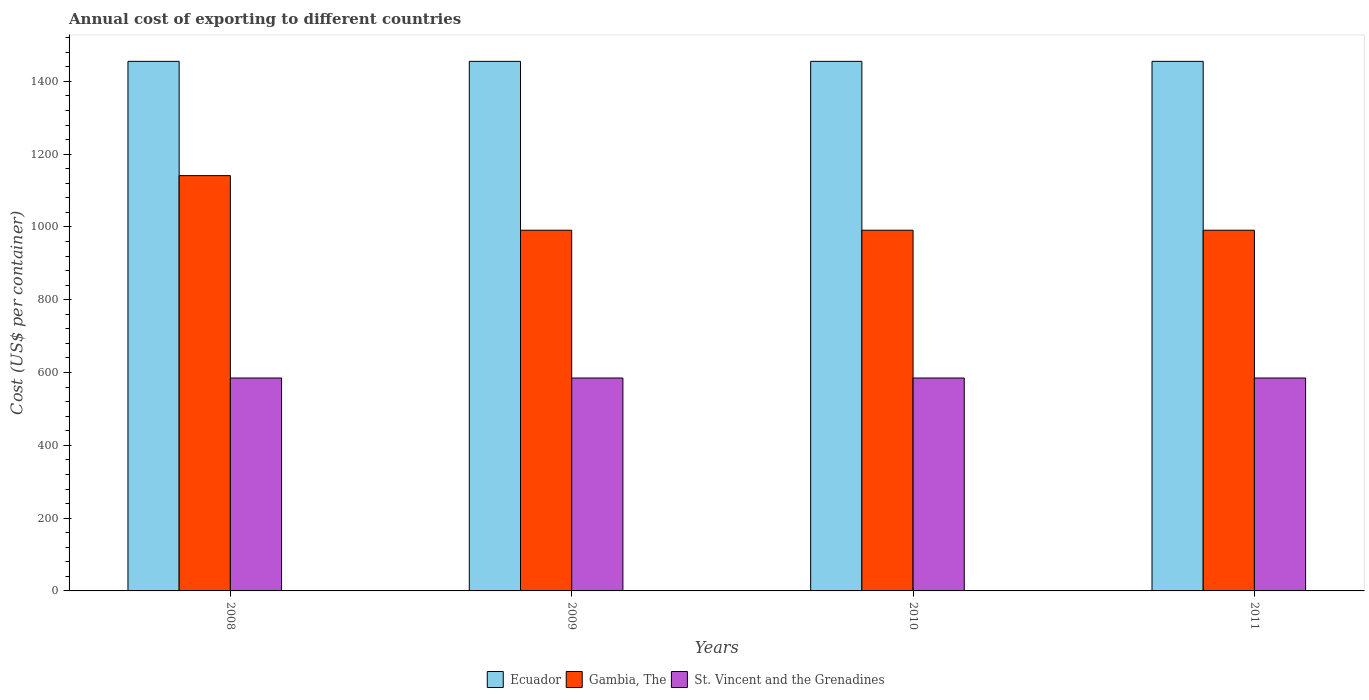How many different coloured bars are there?
Make the answer very short. 3. Are the number of bars on each tick of the X-axis equal?
Make the answer very short. Yes. In how many cases, is the number of bars for a given year not equal to the number of legend labels?
Offer a terse response. 0. What is the total annual cost of exporting in St. Vincent and the Grenadines in 2009?
Give a very brief answer. 585. Across all years, what is the maximum total annual cost of exporting in Ecuador?
Provide a succinct answer. 1455. Across all years, what is the minimum total annual cost of exporting in St. Vincent and the Grenadines?
Offer a terse response. 585. In which year was the total annual cost of exporting in Gambia, The maximum?
Provide a short and direct response. 2008. In which year was the total annual cost of exporting in St. Vincent and the Grenadines minimum?
Your answer should be compact. 2008. What is the total total annual cost of exporting in St. Vincent and the Grenadines in the graph?
Offer a terse response. 2340. What is the difference between the total annual cost of exporting in Gambia, The in 2011 and the total annual cost of exporting in Ecuador in 2009?
Your answer should be very brief. -464. What is the average total annual cost of exporting in St. Vincent and the Grenadines per year?
Your answer should be very brief. 585. In the year 2010, what is the difference between the total annual cost of exporting in Ecuador and total annual cost of exporting in Gambia, The?
Give a very brief answer. 464. In how many years, is the total annual cost of exporting in St. Vincent and the Grenadines greater than 840 US$?
Provide a short and direct response. 0. What is the ratio of the total annual cost of exporting in Gambia, The in 2008 to that in 2009?
Keep it short and to the point. 1.15. Is the total annual cost of exporting in Gambia, The in 2009 less than that in 2010?
Provide a short and direct response. No. What is the difference between the highest and the second highest total annual cost of exporting in St. Vincent and the Grenadines?
Keep it short and to the point. 0. What does the 1st bar from the left in 2008 represents?
Your response must be concise. Ecuador. What does the 3rd bar from the right in 2009 represents?
Provide a short and direct response. Ecuador. Is it the case that in every year, the sum of the total annual cost of exporting in Gambia, The and total annual cost of exporting in Ecuador is greater than the total annual cost of exporting in St. Vincent and the Grenadines?
Offer a terse response. Yes. How many bars are there?
Keep it short and to the point. 12. How many years are there in the graph?
Your answer should be very brief. 4. How are the legend labels stacked?
Your answer should be very brief. Horizontal. What is the title of the graph?
Ensure brevity in your answer.  Annual cost of exporting to different countries. Does "Serbia" appear as one of the legend labels in the graph?
Offer a very short reply. No. What is the label or title of the X-axis?
Your answer should be compact. Years. What is the label or title of the Y-axis?
Make the answer very short. Cost (US$ per container). What is the Cost (US$ per container) of Ecuador in 2008?
Provide a succinct answer. 1455. What is the Cost (US$ per container) of Gambia, The in 2008?
Provide a short and direct response. 1141. What is the Cost (US$ per container) of St. Vincent and the Grenadines in 2008?
Keep it short and to the point. 585. What is the Cost (US$ per container) in Ecuador in 2009?
Your response must be concise. 1455. What is the Cost (US$ per container) of Gambia, The in 2009?
Keep it short and to the point. 991. What is the Cost (US$ per container) of St. Vincent and the Grenadines in 2009?
Provide a succinct answer. 585. What is the Cost (US$ per container) in Ecuador in 2010?
Provide a succinct answer. 1455. What is the Cost (US$ per container) of Gambia, The in 2010?
Keep it short and to the point. 991. What is the Cost (US$ per container) of St. Vincent and the Grenadines in 2010?
Your answer should be compact. 585. What is the Cost (US$ per container) in Ecuador in 2011?
Your response must be concise. 1455. What is the Cost (US$ per container) in Gambia, The in 2011?
Provide a short and direct response. 991. What is the Cost (US$ per container) of St. Vincent and the Grenadines in 2011?
Provide a succinct answer. 585. Across all years, what is the maximum Cost (US$ per container) in Ecuador?
Make the answer very short. 1455. Across all years, what is the maximum Cost (US$ per container) in Gambia, The?
Your answer should be compact. 1141. Across all years, what is the maximum Cost (US$ per container) of St. Vincent and the Grenadines?
Your answer should be compact. 585. Across all years, what is the minimum Cost (US$ per container) in Ecuador?
Your response must be concise. 1455. Across all years, what is the minimum Cost (US$ per container) in Gambia, The?
Provide a short and direct response. 991. Across all years, what is the minimum Cost (US$ per container) in St. Vincent and the Grenadines?
Your response must be concise. 585. What is the total Cost (US$ per container) in Ecuador in the graph?
Provide a succinct answer. 5820. What is the total Cost (US$ per container) in Gambia, The in the graph?
Your answer should be very brief. 4114. What is the total Cost (US$ per container) in St. Vincent and the Grenadines in the graph?
Make the answer very short. 2340. What is the difference between the Cost (US$ per container) in Ecuador in 2008 and that in 2009?
Your response must be concise. 0. What is the difference between the Cost (US$ per container) in Gambia, The in 2008 and that in 2009?
Make the answer very short. 150. What is the difference between the Cost (US$ per container) of St. Vincent and the Grenadines in 2008 and that in 2009?
Keep it short and to the point. 0. What is the difference between the Cost (US$ per container) in Ecuador in 2008 and that in 2010?
Your response must be concise. 0. What is the difference between the Cost (US$ per container) in Gambia, The in 2008 and that in 2010?
Ensure brevity in your answer.  150. What is the difference between the Cost (US$ per container) of Ecuador in 2008 and that in 2011?
Offer a very short reply. 0. What is the difference between the Cost (US$ per container) in Gambia, The in 2008 and that in 2011?
Your answer should be compact. 150. What is the difference between the Cost (US$ per container) of St. Vincent and the Grenadines in 2008 and that in 2011?
Keep it short and to the point. 0. What is the difference between the Cost (US$ per container) in St. Vincent and the Grenadines in 2009 and that in 2010?
Give a very brief answer. 0. What is the difference between the Cost (US$ per container) in Ecuador in 2009 and that in 2011?
Offer a very short reply. 0. What is the difference between the Cost (US$ per container) of Ecuador in 2010 and that in 2011?
Offer a terse response. 0. What is the difference between the Cost (US$ per container) in Gambia, The in 2010 and that in 2011?
Give a very brief answer. 0. What is the difference between the Cost (US$ per container) in Ecuador in 2008 and the Cost (US$ per container) in Gambia, The in 2009?
Offer a very short reply. 464. What is the difference between the Cost (US$ per container) in Ecuador in 2008 and the Cost (US$ per container) in St. Vincent and the Grenadines in 2009?
Your answer should be compact. 870. What is the difference between the Cost (US$ per container) of Gambia, The in 2008 and the Cost (US$ per container) of St. Vincent and the Grenadines in 2009?
Provide a succinct answer. 556. What is the difference between the Cost (US$ per container) of Ecuador in 2008 and the Cost (US$ per container) of Gambia, The in 2010?
Give a very brief answer. 464. What is the difference between the Cost (US$ per container) in Ecuador in 2008 and the Cost (US$ per container) in St. Vincent and the Grenadines in 2010?
Make the answer very short. 870. What is the difference between the Cost (US$ per container) of Gambia, The in 2008 and the Cost (US$ per container) of St. Vincent and the Grenadines in 2010?
Your answer should be compact. 556. What is the difference between the Cost (US$ per container) of Ecuador in 2008 and the Cost (US$ per container) of Gambia, The in 2011?
Provide a short and direct response. 464. What is the difference between the Cost (US$ per container) of Ecuador in 2008 and the Cost (US$ per container) of St. Vincent and the Grenadines in 2011?
Offer a terse response. 870. What is the difference between the Cost (US$ per container) of Gambia, The in 2008 and the Cost (US$ per container) of St. Vincent and the Grenadines in 2011?
Make the answer very short. 556. What is the difference between the Cost (US$ per container) of Ecuador in 2009 and the Cost (US$ per container) of Gambia, The in 2010?
Keep it short and to the point. 464. What is the difference between the Cost (US$ per container) in Ecuador in 2009 and the Cost (US$ per container) in St. Vincent and the Grenadines in 2010?
Ensure brevity in your answer.  870. What is the difference between the Cost (US$ per container) of Gambia, The in 2009 and the Cost (US$ per container) of St. Vincent and the Grenadines in 2010?
Keep it short and to the point. 406. What is the difference between the Cost (US$ per container) of Ecuador in 2009 and the Cost (US$ per container) of Gambia, The in 2011?
Keep it short and to the point. 464. What is the difference between the Cost (US$ per container) in Ecuador in 2009 and the Cost (US$ per container) in St. Vincent and the Grenadines in 2011?
Provide a short and direct response. 870. What is the difference between the Cost (US$ per container) of Gambia, The in 2009 and the Cost (US$ per container) of St. Vincent and the Grenadines in 2011?
Offer a terse response. 406. What is the difference between the Cost (US$ per container) of Ecuador in 2010 and the Cost (US$ per container) of Gambia, The in 2011?
Provide a short and direct response. 464. What is the difference between the Cost (US$ per container) of Ecuador in 2010 and the Cost (US$ per container) of St. Vincent and the Grenadines in 2011?
Make the answer very short. 870. What is the difference between the Cost (US$ per container) of Gambia, The in 2010 and the Cost (US$ per container) of St. Vincent and the Grenadines in 2011?
Give a very brief answer. 406. What is the average Cost (US$ per container) of Ecuador per year?
Make the answer very short. 1455. What is the average Cost (US$ per container) in Gambia, The per year?
Offer a terse response. 1028.5. What is the average Cost (US$ per container) in St. Vincent and the Grenadines per year?
Keep it short and to the point. 585. In the year 2008, what is the difference between the Cost (US$ per container) in Ecuador and Cost (US$ per container) in Gambia, The?
Offer a very short reply. 314. In the year 2008, what is the difference between the Cost (US$ per container) of Ecuador and Cost (US$ per container) of St. Vincent and the Grenadines?
Give a very brief answer. 870. In the year 2008, what is the difference between the Cost (US$ per container) in Gambia, The and Cost (US$ per container) in St. Vincent and the Grenadines?
Offer a very short reply. 556. In the year 2009, what is the difference between the Cost (US$ per container) in Ecuador and Cost (US$ per container) in Gambia, The?
Your answer should be very brief. 464. In the year 2009, what is the difference between the Cost (US$ per container) of Ecuador and Cost (US$ per container) of St. Vincent and the Grenadines?
Keep it short and to the point. 870. In the year 2009, what is the difference between the Cost (US$ per container) of Gambia, The and Cost (US$ per container) of St. Vincent and the Grenadines?
Offer a very short reply. 406. In the year 2010, what is the difference between the Cost (US$ per container) in Ecuador and Cost (US$ per container) in Gambia, The?
Your answer should be very brief. 464. In the year 2010, what is the difference between the Cost (US$ per container) in Ecuador and Cost (US$ per container) in St. Vincent and the Grenadines?
Provide a short and direct response. 870. In the year 2010, what is the difference between the Cost (US$ per container) in Gambia, The and Cost (US$ per container) in St. Vincent and the Grenadines?
Keep it short and to the point. 406. In the year 2011, what is the difference between the Cost (US$ per container) in Ecuador and Cost (US$ per container) in Gambia, The?
Keep it short and to the point. 464. In the year 2011, what is the difference between the Cost (US$ per container) of Ecuador and Cost (US$ per container) of St. Vincent and the Grenadines?
Your answer should be compact. 870. In the year 2011, what is the difference between the Cost (US$ per container) in Gambia, The and Cost (US$ per container) in St. Vincent and the Grenadines?
Make the answer very short. 406. What is the ratio of the Cost (US$ per container) of Ecuador in 2008 to that in 2009?
Your answer should be compact. 1. What is the ratio of the Cost (US$ per container) of Gambia, The in 2008 to that in 2009?
Make the answer very short. 1.15. What is the ratio of the Cost (US$ per container) of St. Vincent and the Grenadines in 2008 to that in 2009?
Provide a short and direct response. 1. What is the ratio of the Cost (US$ per container) of Ecuador in 2008 to that in 2010?
Your answer should be very brief. 1. What is the ratio of the Cost (US$ per container) in Gambia, The in 2008 to that in 2010?
Ensure brevity in your answer.  1.15. What is the ratio of the Cost (US$ per container) in St. Vincent and the Grenadines in 2008 to that in 2010?
Provide a short and direct response. 1. What is the ratio of the Cost (US$ per container) in Ecuador in 2008 to that in 2011?
Your answer should be compact. 1. What is the ratio of the Cost (US$ per container) in Gambia, The in 2008 to that in 2011?
Keep it short and to the point. 1.15. What is the ratio of the Cost (US$ per container) in Gambia, The in 2009 to that in 2010?
Ensure brevity in your answer.  1. What is the ratio of the Cost (US$ per container) of Gambia, The in 2009 to that in 2011?
Your answer should be compact. 1. What is the ratio of the Cost (US$ per container) of St. Vincent and the Grenadines in 2009 to that in 2011?
Your response must be concise. 1. What is the ratio of the Cost (US$ per container) in Ecuador in 2010 to that in 2011?
Your answer should be compact. 1. What is the ratio of the Cost (US$ per container) in Gambia, The in 2010 to that in 2011?
Offer a terse response. 1. What is the difference between the highest and the second highest Cost (US$ per container) in Ecuador?
Offer a terse response. 0. What is the difference between the highest and the second highest Cost (US$ per container) in Gambia, The?
Provide a succinct answer. 150. What is the difference between the highest and the lowest Cost (US$ per container) in Ecuador?
Offer a terse response. 0. What is the difference between the highest and the lowest Cost (US$ per container) in Gambia, The?
Provide a succinct answer. 150. What is the difference between the highest and the lowest Cost (US$ per container) of St. Vincent and the Grenadines?
Make the answer very short. 0. 